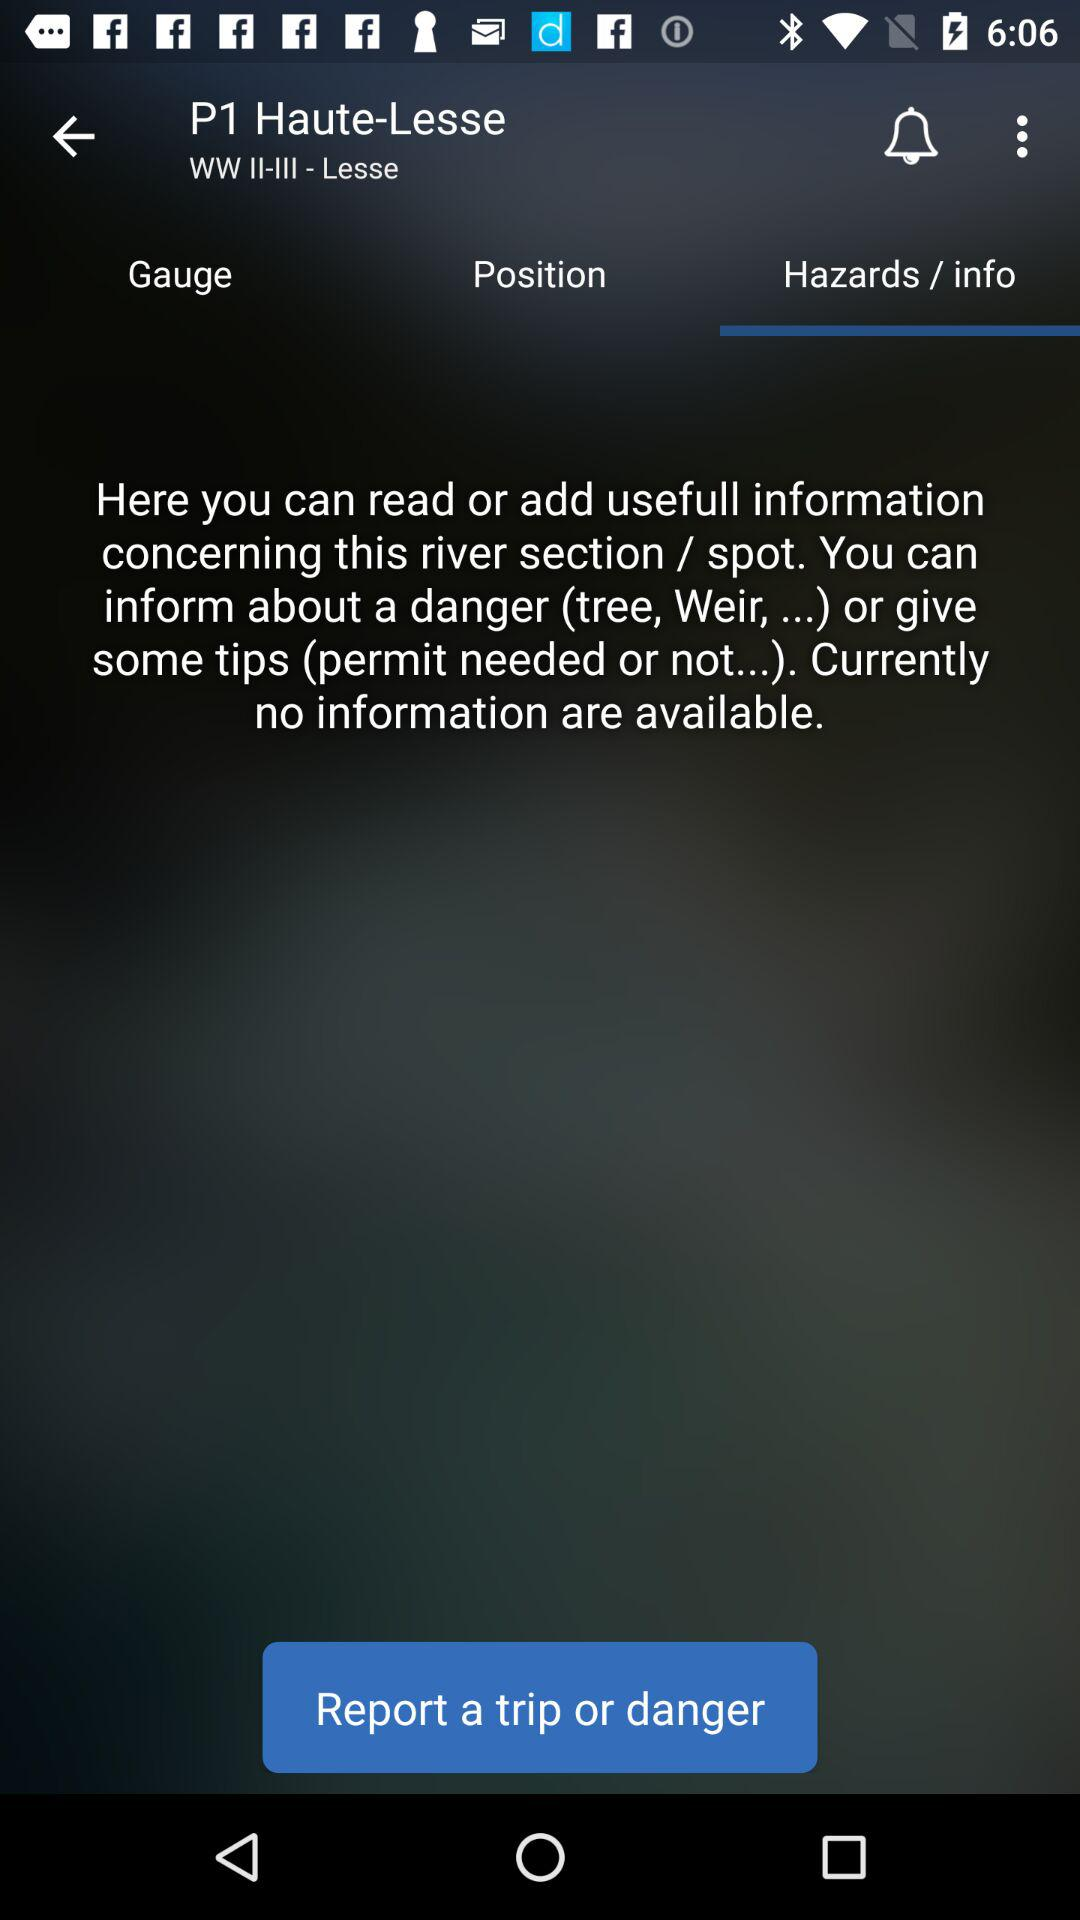Which option is selected? The selected option is "Hazards / info". 